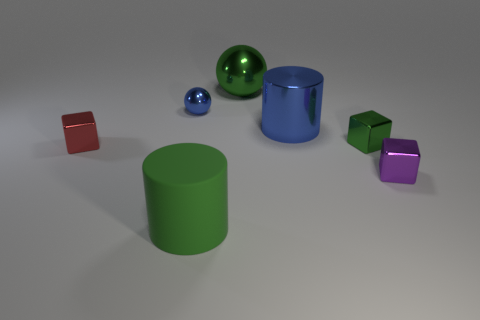Does the metal cylinder have the same color as the small sphere?
Give a very brief answer. Yes. There is a cube left of the green shiny block; how big is it?
Offer a terse response. Small. Is the color of the big shiny object that is behind the small ball the same as the cylinder in front of the small purple object?
Make the answer very short. Yes. What number of other objects are there of the same shape as the large matte object?
Offer a terse response. 1. Is the number of tiny purple things that are in front of the small blue shiny sphere the same as the number of large green matte cylinders behind the small green metal thing?
Your answer should be very brief. No. Do the small block behind the tiny red object and the tiny thing that is on the right side of the tiny green shiny thing have the same material?
Your answer should be compact. Yes. What number of other objects are there of the same size as the green matte object?
Provide a short and direct response. 2. How many things are either big shiny things or objects left of the large blue metallic object?
Your answer should be compact. 5. Is the number of tiny green metallic blocks that are to the left of the purple thing the same as the number of large yellow objects?
Your answer should be compact. No. There is a big blue object that is made of the same material as the purple cube; what shape is it?
Provide a succinct answer. Cylinder. 